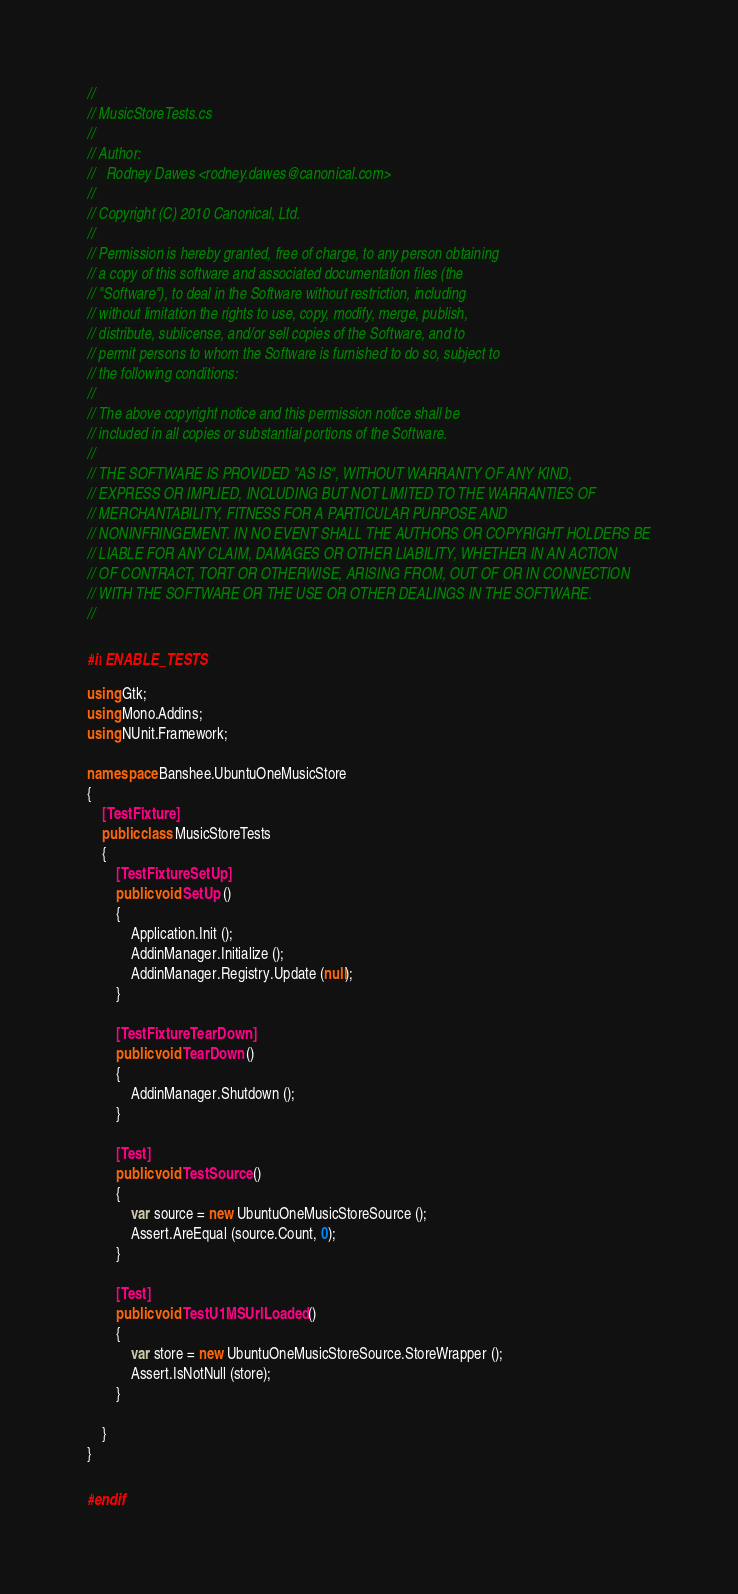<code> <loc_0><loc_0><loc_500><loc_500><_C#_>//
// MusicStoreTests.cs
//
// Author:
//   Rodney Dawes <rodney.dawes@canonical.com>
//
// Copyright (C) 2010 Canonical, Ltd.
//
// Permission is hereby granted, free of charge, to any person obtaining
// a copy of this software and associated documentation files (the
// "Software"), to deal in the Software without restriction, including
// without limitation the rights to use, copy, modify, merge, publish,
// distribute, sublicense, and/or sell copies of the Software, and to
// permit persons to whom the Software is furnished to do so, subject to
// the following conditions:
//
// The above copyright notice and this permission notice shall be
// included in all copies or substantial portions of the Software.
//
// THE SOFTWARE IS PROVIDED "AS IS", WITHOUT WARRANTY OF ANY KIND,
// EXPRESS OR IMPLIED, INCLUDING BUT NOT LIMITED TO THE WARRANTIES OF
// MERCHANTABILITY, FITNESS FOR A PARTICULAR PURPOSE AND
// NONINFRINGEMENT. IN NO EVENT SHALL THE AUTHORS OR COPYRIGHT HOLDERS BE
// LIABLE FOR ANY CLAIM, DAMAGES OR OTHER LIABILITY, WHETHER IN AN ACTION
// OF CONTRACT, TORT OR OTHERWISE, ARISING FROM, OUT OF OR IN CONNECTION
// WITH THE SOFTWARE OR THE USE OR OTHER DEALINGS IN THE SOFTWARE.
//

#if ENABLE_TESTS

using Gtk;
using Mono.Addins;
using NUnit.Framework;

namespace Banshee.UbuntuOneMusicStore
{
    [TestFixture]
    public class MusicStoreTests
    {
        [TestFixtureSetUp]
        public void SetUp ()
        {
            Application.Init ();
            AddinManager.Initialize ();
            AddinManager.Registry.Update (null);
        }

        [TestFixtureTearDown]
        public void TearDown ()
        {
            AddinManager.Shutdown ();
        }

        [Test]
        public void TestSource ()
        {
            var source = new UbuntuOneMusicStoreSource ();
            Assert.AreEqual (source.Count, 0);
        }

        [Test]
        public void TestU1MSUrlLoaded ()
        {
            var store = new UbuntuOneMusicStoreSource.StoreWrapper ();
            Assert.IsNotNull (store);
        }

    }
}

#endif
</code> 